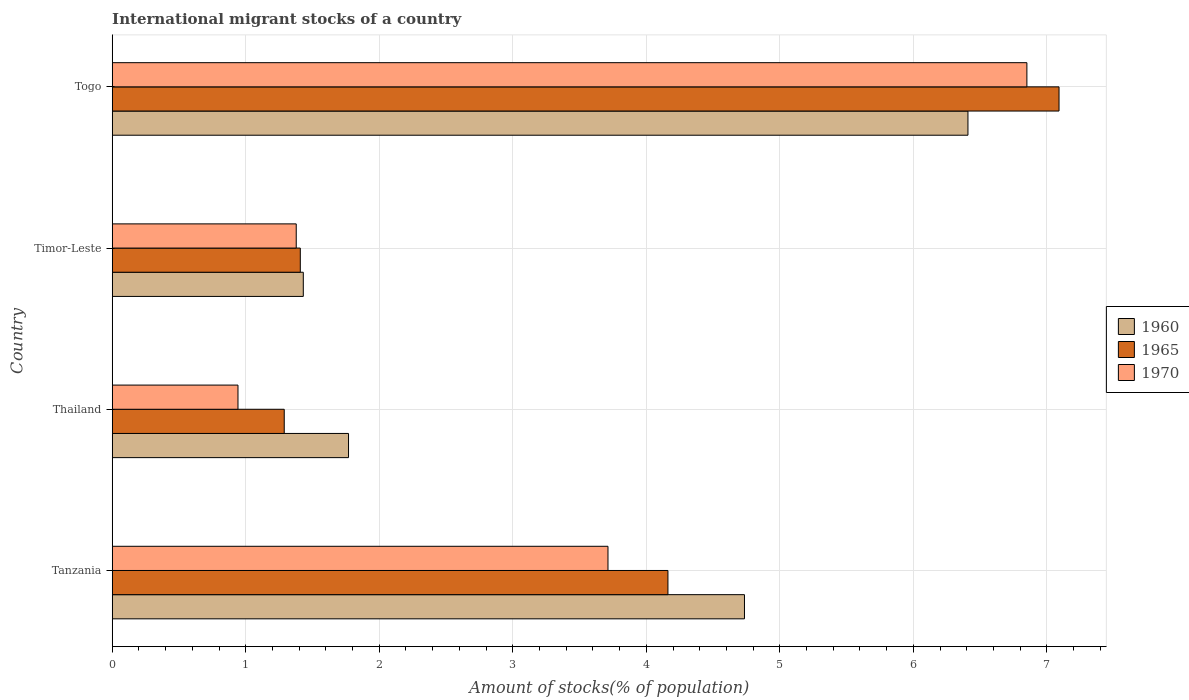How many groups of bars are there?
Offer a very short reply. 4. Are the number of bars per tick equal to the number of legend labels?
Your answer should be compact. Yes. Are the number of bars on each tick of the Y-axis equal?
Make the answer very short. Yes. How many bars are there on the 1st tick from the bottom?
Your response must be concise. 3. What is the label of the 3rd group of bars from the top?
Make the answer very short. Thailand. What is the amount of stocks in in 1965 in Timor-Leste?
Your answer should be compact. 1.41. Across all countries, what is the maximum amount of stocks in in 1960?
Make the answer very short. 6.41. Across all countries, what is the minimum amount of stocks in in 1970?
Your answer should be very brief. 0.94. In which country was the amount of stocks in in 1965 maximum?
Give a very brief answer. Togo. In which country was the amount of stocks in in 1970 minimum?
Provide a succinct answer. Thailand. What is the total amount of stocks in in 1960 in the graph?
Keep it short and to the point. 14.34. What is the difference between the amount of stocks in in 1970 in Tanzania and that in Togo?
Your answer should be very brief. -3.14. What is the difference between the amount of stocks in in 1965 in Thailand and the amount of stocks in in 1960 in Tanzania?
Your answer should be compact. -3.45. What is the average amount of stocks in in 1965 per country?
Offer a terse response. 3.49. What is the difference between the amount of stocks in in 1970 and amount of stocks in in 1965 in Tanzania?
Your response must be concise. -0.45. In how many countries, is the amount of stocks in in 1965 greater than 1.6 %?
Your answer should be compact. 2. What is the ratio of the amount of stocks in in 1965 in Thailand to that in Togo?
Your answer should be compact. 0.18. What is the difference between the highest and the second highest amount of stocks in in 1960?
Your response must be concise. 1.67. What is the difference between the highest and the lowest amount of stocks in in 1960?
Provide a succinct answer. 4.98. Is the sum of the amount of stocks in in 1965 in Timor-Leste and Togo greater than the maximum amount of stocks in in 1970 across all countries?
Your response must be concise. Yes. What does the 2nd bar from the top in Tanzania represents?
Give a very brief answer. 1965. What does the 1st bar from the bottom in Timor-Leste represents?
Your response must be concise. 1960. How many legend labels are there?
Offer a very short reply. 3. What is the title of the graph?
Give a very brief answer. International migrant stocks of a country. Does "1998" appear as one of the legend labels in the graph?
Provide a succinct answer. No. What is the label or title of the X-axis?
Offer a very short reply. Amount of stocks(% of population). What is the Amount of stocks(% of population) of 1960 in Tanzania?
Your answer should be very brief. 4.73. What is the Amount of stocks(% of population) of 1965 in Tanzania?
Offer a terse response. 4.16. What is the Amount of stocks(% of population) of 1970 in Tanzania?
Give a very brief answer. 3.71. What is the Amount of stocks(% of population) of 1960 in Thailand?
Make the answer very short. 1.77. What is the Amount of stocks(% of population) of 1965 in Thailand?
Your answer should be very brief. 1.29. What is the Amount of stocks(% of population) of 1970 in Thailand?
Give a very brief answer. 0.94. What is the Amount of stocks(% of population) in 1960 in Timor-Leste?
Keep it short and to the point. 1.43. What is the Amount of stocks(% of population) in 1965 in Timor-Leste?
Offer a terse response. 1.41. What is the Amount of stocks(% of population) of 1970 in Timor-Leste?
Provide a succinct answer. 1.38. What is the Amount of stocks(% of population) of 1960 in Togo?
Ensure brevity in your answer.  6.41. What is the Amount of stocks(% of population) in 1965 in Togo?
Keep it short and to the point. 7.09. What is the Amount of stocks(% of population) in 1970 in Togo?
Your answer should be compact. 6.85. Across all countries, what is the maximum Amount of stocks(% of population) of 1960?
Make the answer very short. 6.41. Across all countries, what is the maximum Amount of stocks(% of population) of 1965?
Give a very brief answer. 7.09. Across all countries, what is the maximum Amount of stocks(% of population) of 1970?
Your answer should be compact. 6.85. Across all countries, what is the minimum Amount of stocks(% of population) of 1960?
Keep it short and to the point. 1.43. Across all countries, what is the minimum Amount of stocks(% of population) in 1965?
Provide a succinct answer. 1.29. Across all countries, what is the minimum Amount of stocks(% of population) in 1970?
Offer a very short reply. 0.94. What is the total Amount of stocks(% of population) of 1960 in the graph?
Offer a very short reply. 14.34. What is the total Amount of stocks(% of population) of 1965 in the graph?
Your response must be concise. 13.95. What is the total Amount of stocks(% of population) in 1970 in the graph?
Ensure brevity in your answer.  12.88. What is the difference between the Amount of stocks(% of population) of 1960 in Tanzania and that in Thailand?
Offer a very short reply. 2.97. What is the difference between the Amount of stocks(% of population) of 1965 in Tanzania and that in Thailand?
Make the answer very short. 2.87. What is the difference between the Amount of stocks(% of population) of 1970 in Tanzania and that in Thailand?
Provide a succinct answer. 2.77. What is the difference between the Amount of stocks(% of population) in 1960 in Tanzania and that in Timor-Leste?
Keep it short and to the point. 3.3. What is the difference between the Amount of stocks(% of population) in 1965 in Tanzania and that in Timor-Leste?
Make the answer very short. 2.75. What is the difference between the Amount of stocks(% of population) of 1970 in Tanzania and that in Timor-Leste?
Your answer should be compact. 2.33. What is the difference between the Amount of stocks(% of population) in 1960 in Tanzania and that in Togo?
Your answer should be very brief. -1.67. What is the difference between the Amount of stocks(% of population) in 1965 in Tanzania and that in Togo?
Offer a very short reply. -2.93. What is the difference between the Amount of stocks(% of population) in 1970 in Tanzania and that in Togo?
Make the answer very short. -3.14. What is the difference between the Amount of stocks(% of population) of 1960 in Thailand and that in Timor-Leste?
Your response must be concise. 0.34. What is the difference between the Amount of stocks(% of population) of 1965 in Thailand and that in Timor-Leste?
Offer a terse response. -0.12. What is the difference between the Amount of stocks(% of population) in 1970 in Thailand and that in Timor-Leste?
Your answer should be compact. -0.44. What is the difference between the Amount of stocks(% of population) in 1960 in Thailand and that in Togo?
Give a very brief answer. -4.64. What is the difference between the Amount of stocks(% of population) of 1965 in Thailand and that in Togo?
Make the answer very short. -5.8. What is the difference between the Amount of stocks(% of population) of 1970 in Thailand and that in Togo?
Provide a succinct answer. -5.91. What is the difference between the Amount of stocks(% of population) of 1960 in Timor-Leste and that in Togo?
Ensure brevity in your answer.  -4.98. What is the difference between the Amount of stocks(% of population) in 1965 in Timor-Leste and that in Togo?
Your answer should be compact. -5.68. What is the difference between the Amount of stocks(% of population) of 1970 in Timor-Leste and that in Togo?
Make the answer very short. -5.47. What is the difference between the Amount of stocks(% of population) of 1960 in Tanzania and the Amount of stocks(% of population) of 1965 in Thailand?
Give a very brief answer. 3.45. What is the difference between the Amount of stocks(% of population) in 1960 in Tanzania and the Amount of stocks(% of population) in 1970 in Thailand?
Offer a very short reply. 3.79. What is the difference between the Amount of stocks(% of population) in 1965 in Tanzania and the Amount of stocks(% of population) in 1970 in Thailand?
Offer a very short reply. 3.22. What is the difference between the Amount of stocks(% of population) of 1960 in Tanzania and the Amount of stocks(% of population) of 1965 in Timor-Leste?
Make the answer very short. 3.33. What is the difference between the Amount of stocks(% of population) in 1960 in Tanzania and the Amount of stocks(% of population) in 1970 in Timor-Leste?
Provide a short and direct response. 3.36. What is the difference between the Amount of stocks(% of population) in 1965 in Tanzania and the Amount of stocks(% of population) in 1970 in Timor-Leste?
Offer a terse response. 2.78. What is the difference between the Amount of stocks(% of population) in 1960 in Tanzania and the Amount of stocks(% of population) in 1965 in Togo?
Give a very brief answer. -2.36. What is the difference between the Amount of stocks(% of population) of 1960 in Tanzania and the Amount of stocks(% of population) of 1970 in Togo?
Make the answer very short. -2.12. What is the difference between the Amount of stocks(% of population) in 1965 in Tanzania and the Amount of stocks(% of population) in 1970 in Togo?
Your answer should be very brief. -2.69. What is the difference between the Amount of stocks(% of population) of 1960 in Thailand and the Amount of stocks(% of population) of 1965 in Timor-Leste?
Provide a succinct answer. 0.36. What is the difference between the Amount of stocks(% of population) in 1960 in Thailand and the Amount of stocks(% of population) in 1970 in Timor-Leste?
Ensure brevity in your answer.  0.39. What is the difference between the Amount of stocks(% of population) in 1965 in Thailand and the Amount of stocks(% of population) in 1970 in Timor-Leste?
Offer a terse response. -0.09. What is the difference between the Amount of stocks(% of population) of 1960 in Thailand and the Amount of stocks(% of population) of 1965 in Togo?
Your response must be concise. -5.32. What is the difference between the Amount of stocks(% of population) of 1960 in Thailand and the Amount of stocks(% of population) of 1970 in Togo?
Make the answer very short. -5.08. What is the difference between the Amount of stocks(% of population) of 1965 in Thailand and the Amount of stocks(% of population) of 1970 in Togo?
Offer a very short reply. -5.56. What is the difference between the Amount of stocks(% of population) of 1960 in Timor-Leste and the Amount of stocks(% of population) of 1965 in Togo?
Provide a short and direct response. -5.66. What is the difference between the Amount of stocks(% of population) of 1960 in Timor-Leste and the Amount of stocks(% of population) of 1970 in Togo?
Offer a terse response. -5.42. What is the difference between the Amount of stocks(% of population) in 1965 in Timor-Leste and the Amount of stocks(% of population) in 1970 in Togo?
Offer a very short reply. -5.44. What is the average Amount of stocks(% of population) in 1960 per country?
Offer a terse response. 3.59. What is the average Amount of stocks(% of population) of 1965 per country?
Give a very brief answer. 3.49. What is the average Amount of stocks(% of population) of 1970 per country?
Offer a very short reply. 3.22. What is the difference between the Amount of stocks(% of population) of 1960 and Amount of stocks(% of population) of 1965 in Tanzania?
Make the answer very short. 0.57. What is the difference between the Amount of stocks(% of population) of 1960 and Amount of stocks(% of population) of 1970 in Tanzania?
Your response must be concise. 1.02. What is the difference between the Amount of stocks(% of population) in 1965 and Amount of stocks(% of population) in 1970 in Tanzania?
Provide a succinct answer. 0.45. What is the difference between the Amount of stocks(% of population) of 1960 and Amount of stocks(% of population) of 1965 in Thailand?
Your answer should be very brief. 0.48. What is the difference between the Amount of stocks(% of population) of 1960 and Amount of stocks(% of population) of 1970 in Thailand?
Make the answer very short. 0.83. What is the difference between the Amount of stocks(% of population) of 1965 and Amount of stocks(% of population) of 1970 in Thailand?
Give a very brief answer. 0.35. What is the difference between the Amount of stocks(% of population) of 1960 and Amount of stocks(% of population) of 1965 in Timor-Leste?
Provide a short and direct response. 0.02. What is the difference between the Amount of stocks(% of population) in 1960 and Amount of stocks(% of population) in 1970 in Timor-Leste?
Make the answer very short. 0.05. What is the difference between the Amount of stocks(% of population) of 1965 and Amount of stocks(% of population) of 1970 in Timor-Leste?
Give a very brief answer. 0.03. What is the difference between the Amount of stocks(% of population) of 1960 and Amount of stocks(% of population) of 1965 in Togo?
Your response must be concise. -0.68. What is the difference between the Amount of stocks(% of population) of 1960 and Amount of stocks(% of population) of 1970 in Togo?
Your answer should be very brief. -0.44. What is the difference between the Amount of stocks(% of population) of 1965 and Amount of stocks(% of population) of 1970 in Togo?
Your answer should be very brief. 0.24. What is the ratio of the Amount of stocks(% of population) in 1960 in Tanzania to that in Thailand?
Ensure brevity in your answer.  2.68. What is the ratio of the Amount of stocks(% of population) in 1965 in Tanzania to that in Thailand?
Offer a terse response. 3.23. What is the ratio of the Amount of stocks(% of population) of 1970 in Tanzania to that in Thailand?
Give a very brief answer. 3.94. What is the ratio of the Amount of stocks(% of population) in 1960 in Tanzania to that in Timor-Leste?
Your response must be concise. 3.31. What is the ratio of the Amount of stocks(% of population) in 1965 in Tanzania to that in Timor-Leste?
Give a very brief answer. 2.95. What is the ratio of the Amount of stocks(% of population) in 1970 in Tanzania to that in Timor-Leste?
Your answer should be compact. 2.69. What is the ratio of the Amount of stocks(% of population) in 1960 in Tanzania to that in Togo?
Give a very brief answer. 0.74. What is the ratio of the Amount of stocks(% of population) in 1965 in Tanzania to that in Togo?
Offer a very short reply. 0.59. What is the ratio of the Amount of stocks(% of population) of 1970 in Tanzania to that in Togo?
Give a very brief answer. 0.54. What is the ratio of the Amount of stocks(% of population) in 1960 in Thailand to that in Timor-Leste?
Offer a terse response. 1.24. What is the ratio of the Amount of stocks(% of population) of 1965 in Thailand to that in Timor-Leste?
Make the answer very short. 0.91. What is the ratio of the Amount of stocks(% of population) of 1970 in Thailand to that in Timor-Leste?
Provide a short and direct response. 0.68. What is the ratio of the Amount of stocks(% of population) in 1960 in Thailand to that in Togo?
Your answer should be very brief. 0.28. What is the ratio of the Amount of stocks(% of population) of 1965 in Thailand to that in Togo?
Ensure brevity in your answer.  0.18. What is the ratio of the Amount of stocks(% of population) of 1970 in Thailand to that in Togo?
Your answer should be very brief. 0.14. What is the ratio of the Amount of stocks(% of population) of 1960 in Timor-Leste to that in Togo?
Your response must be concise. 0.22. What is the ratio of the Amount of stocks(% of population) of 1965 in Timor-Leste to that in Togo?
Keep it short and to the point. 0.2. What is the ratio of the Amount of stocks(% of population) of 1970 in Timor-Leste to that in Togo?
Provide a succinct answer. 0.2. What is the difference between the highest and the second highest Amount of stocks(% of population) of 1960?
Make the answer very short. 1.67. What is the difference between the highest and the second highest Amount of stocks(% of population) of 1965?
Make the answer very short. 2.93. What is the difference between the highest and the second highest Amount of stocks(% of population) of 1970?
Provide a short and direct response. 3.14. What is the difference between the highest and the lowest Amount of stocks(% of population) in 1960?
Provide a short and direct response. 4.98. What is the difference between the highest and the lowest Amount of stocks(% of population) in 1965?
Your answer should be very brief. 5.8. What is the difference between the highest and the lowest Amount of stocks(% of population) in 1970?
Your answer should be very brief. 5.91. 